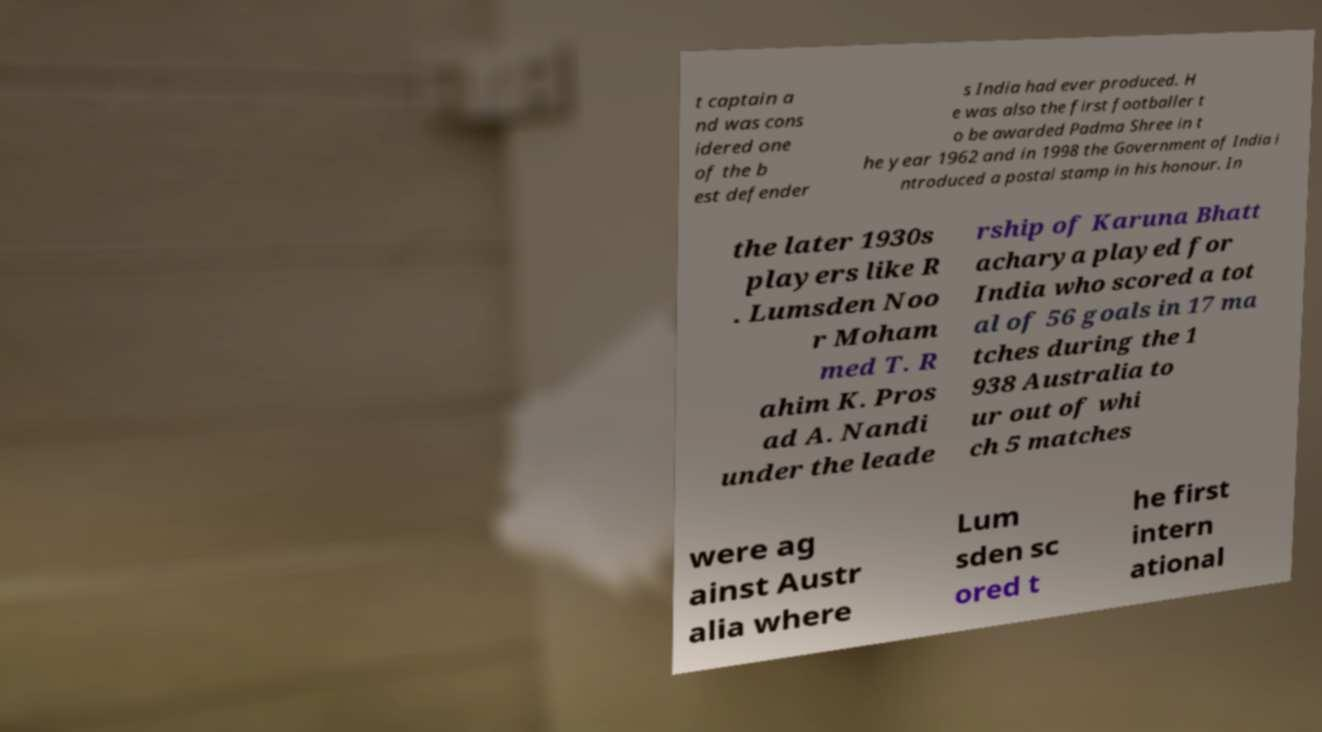There's text embedded in this image that I need extracted. Can you transcribe it verbatim? t captain a nd was cons idered one of the b est defender s India had ever produced. H e was also the first footballer t o be awarded Padma Shree in t he year 1962 and in 1998 the Government of India i ntroduced a postal stamp in his honour. In the later 1930s players like R . Lumsden Noo r Moham med T. R ahim K. Pros ad A. Nandi under the leade rship of Karuna Bhatt acharya played for India who scored a tot al of 56 goals in 17 ma tches during the 1 938 Australia to ur out of whi ch 5 matches were ag ainst Austr alia where Lum sden sc ored t he first intern ational 